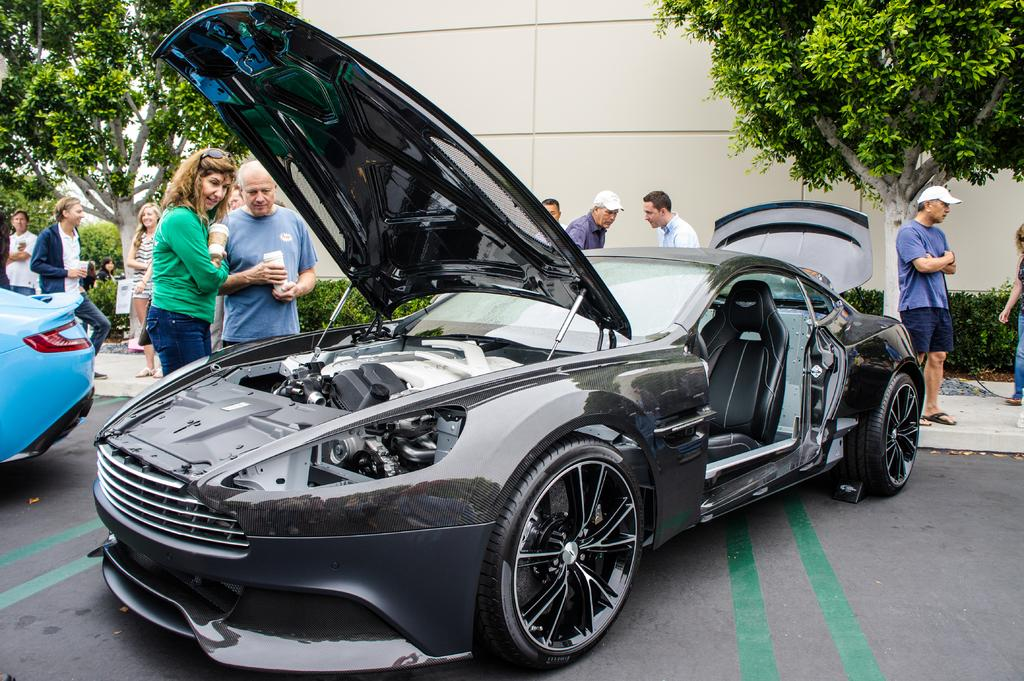What type of vehicles can be seen on the road in the image? There are motor vehicles on the road in the image. What else can be seen in the image besides the vehicles? There are persons standing in the image. What is visible in the background of the image? There is sky, trees, bushes, and a building visible in the background of the image. What date is marked on the calendar in the image? There is no calendar present in the image. What type of stem can be seen growing from the top of the building in the image? There is no stem or plant growing from the top of the building in the image. 